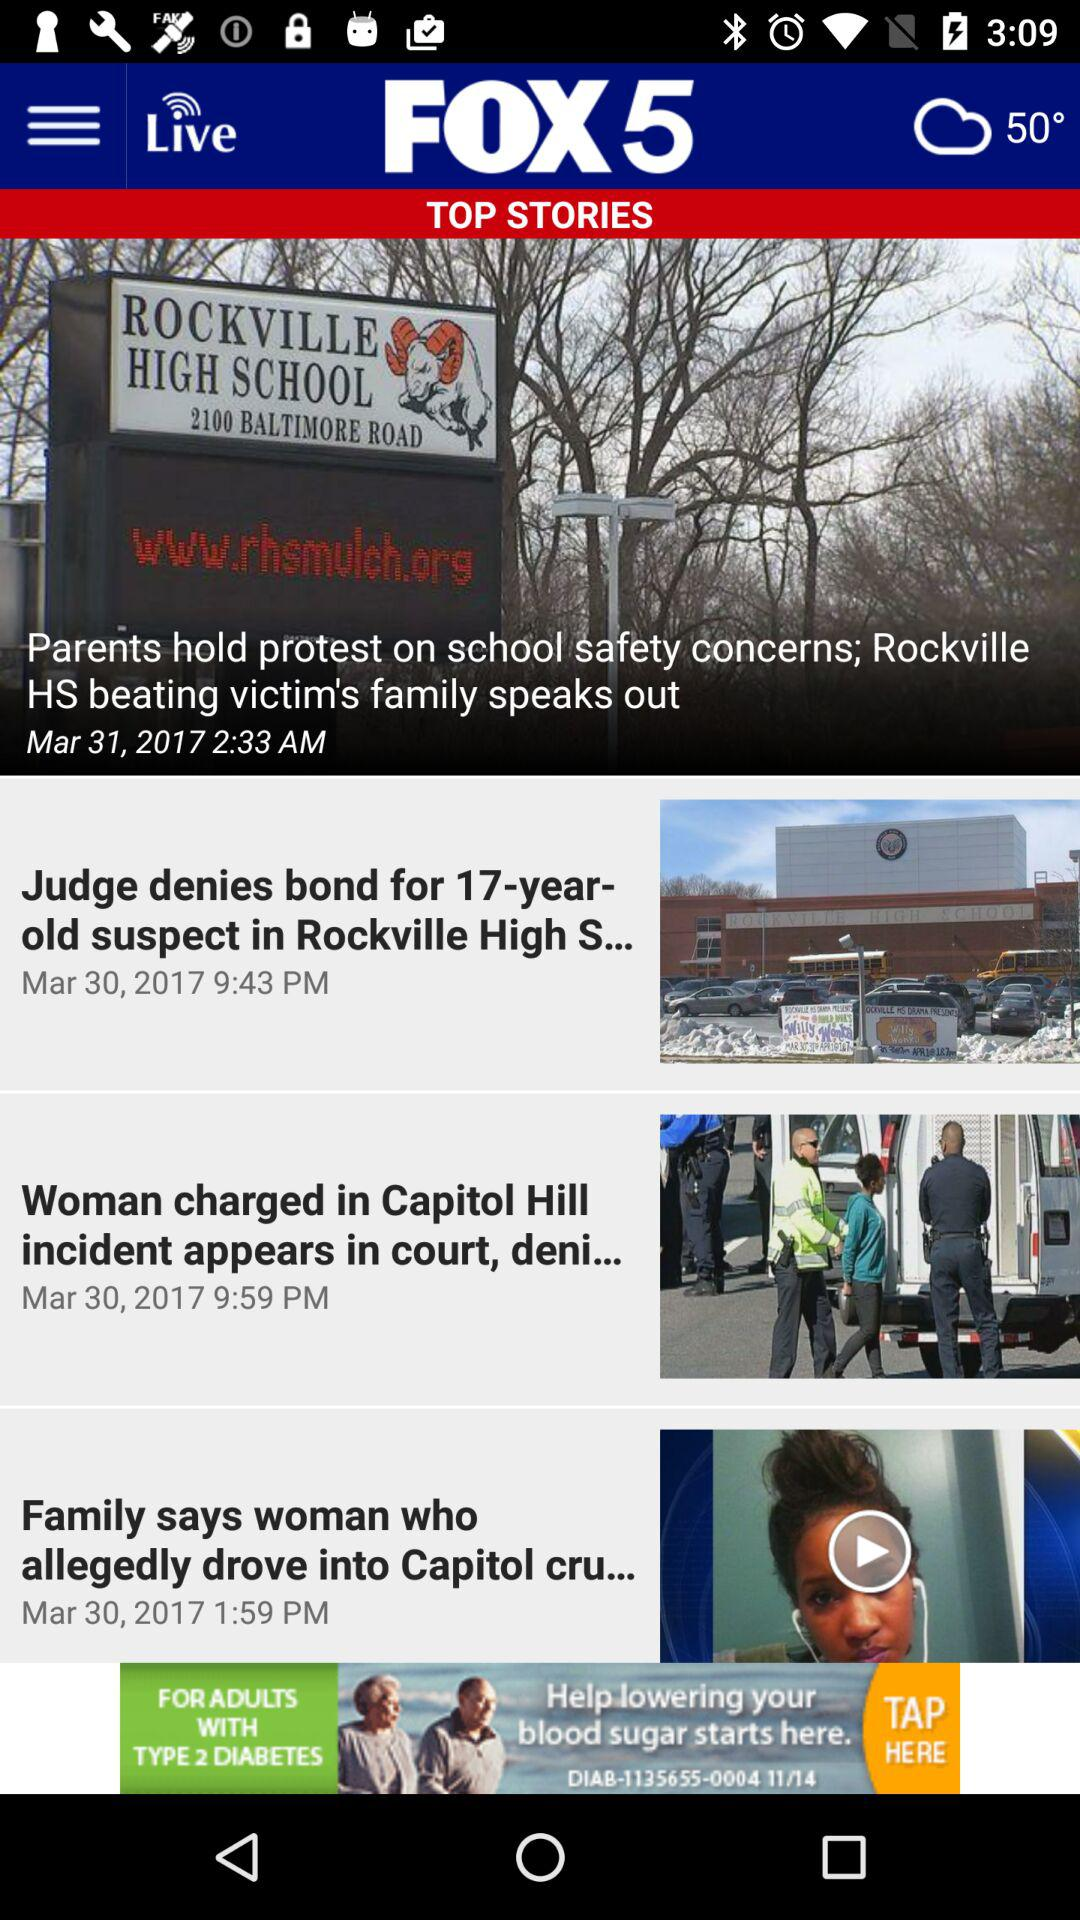What is the name of the application? The name of the application is "FOX 5". 